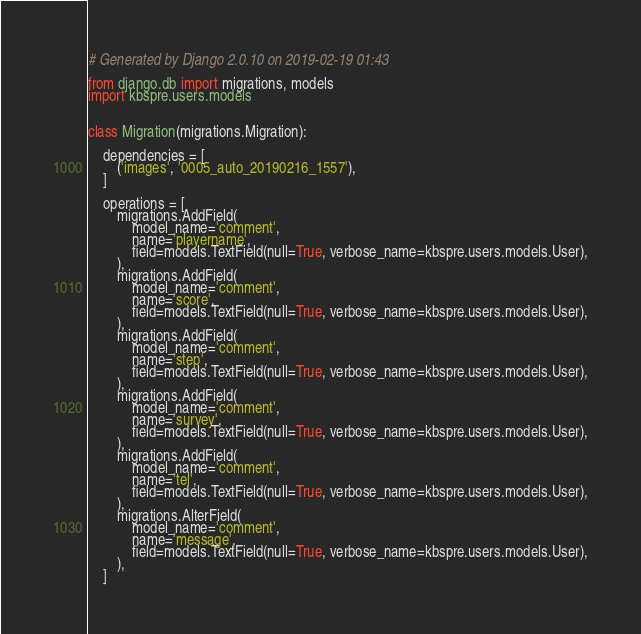<code> <loc_0><loc_0><loc_500><loc_500><_Python_># Generated by Django 2.0.10 on 2019-02-19 01:43

from django.db import migrations, models
import kbspre.users.models


class Migration(migrations.Migration):

    dependencies = [
        ('images', '0005_auto_20190216_1557'),
    ]

    operations = [
        migrations.AddField(
            model_name='comment',
            name='playername',
            field=models.TextField(null=True, verbose_name=kbspre.users.models.User),
        ),
        migrations.AddField(
            model_name='comment',
            name='score',
            field=models.TextField(null=True, verbose_name=kbspre.users.models.User),
        ),
        migrations.AddField(
            model_name='comment',
            name='step',
            field=models.TextField(null=True, verbose_name=kbspre.users.models.User),
        ),
        migrations.AddField(
            model_name='comment',
            name='survey',
            field=models.TextField(null=True, verbose_name=kbspre.users.models.User),
        ),
        migrations.AddField(
            model_name='comment',
            name='tel',
            field=models.TextField(null=True, verbose_name=kbspre.users.models.User),
        ),
        migrations.AlterField(
            model_name='comment',
            name='message',
            field=models.TextField(null=True, verbose_name=kbspre.users.models.User),
        ),
    ]
</code> 